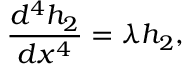Convert formula to latex. <formula><loc_0><loc_0><loc_500><loc_500>\frac { d ^ { 4 } h _ { 2 } } { d x ^ { 4 } } = \lambda h _ { 2 } ,</formula> 